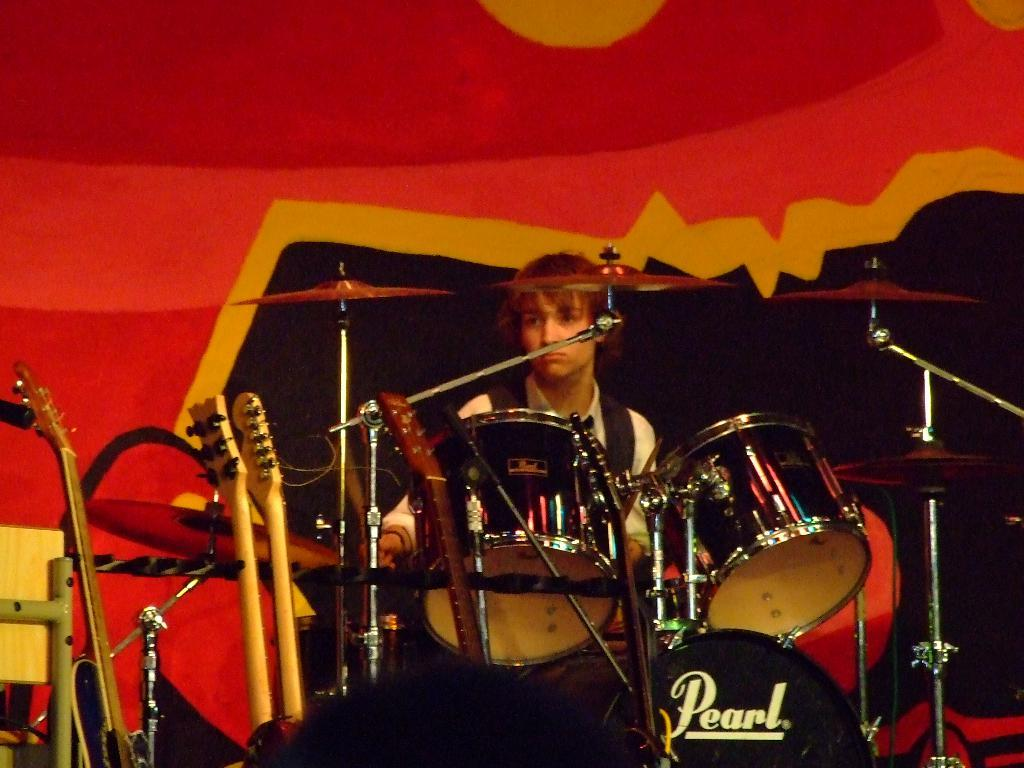What is the main activity being performed in the image? There is a person playing drums in the image. What other musical instruments are present in the image? There are three guitars in the image. What word is written on one of the drums? The word "pearl" is written on a drum. How many pizzas are being served to the parent in the image? There are no pizzas or parents present in the image. What story is being told by the person playing drums in the image? The image does not depict a story being told; it shows a person playing drums and other musical instruments. 